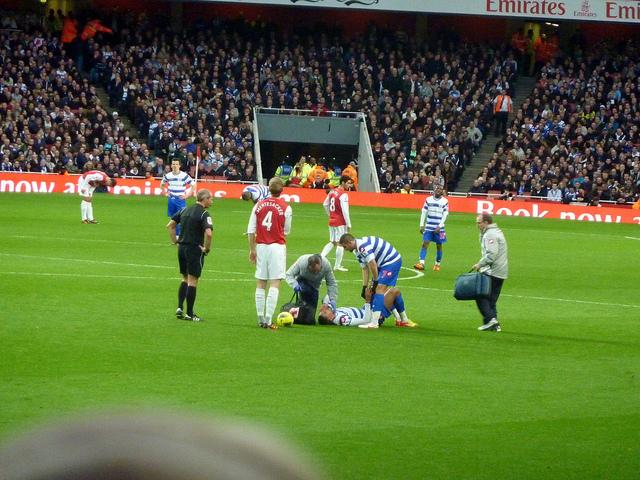Where are the players playing?
Answer briefly. Field. What team is playing?
Answer briefly. Soccer. Is there available seating to watch the game?
Short answer required. No. What does it say on the back fence, right side?
Be succinct. Book now. What sport are they playing?
Keep it brief. Soccer. 